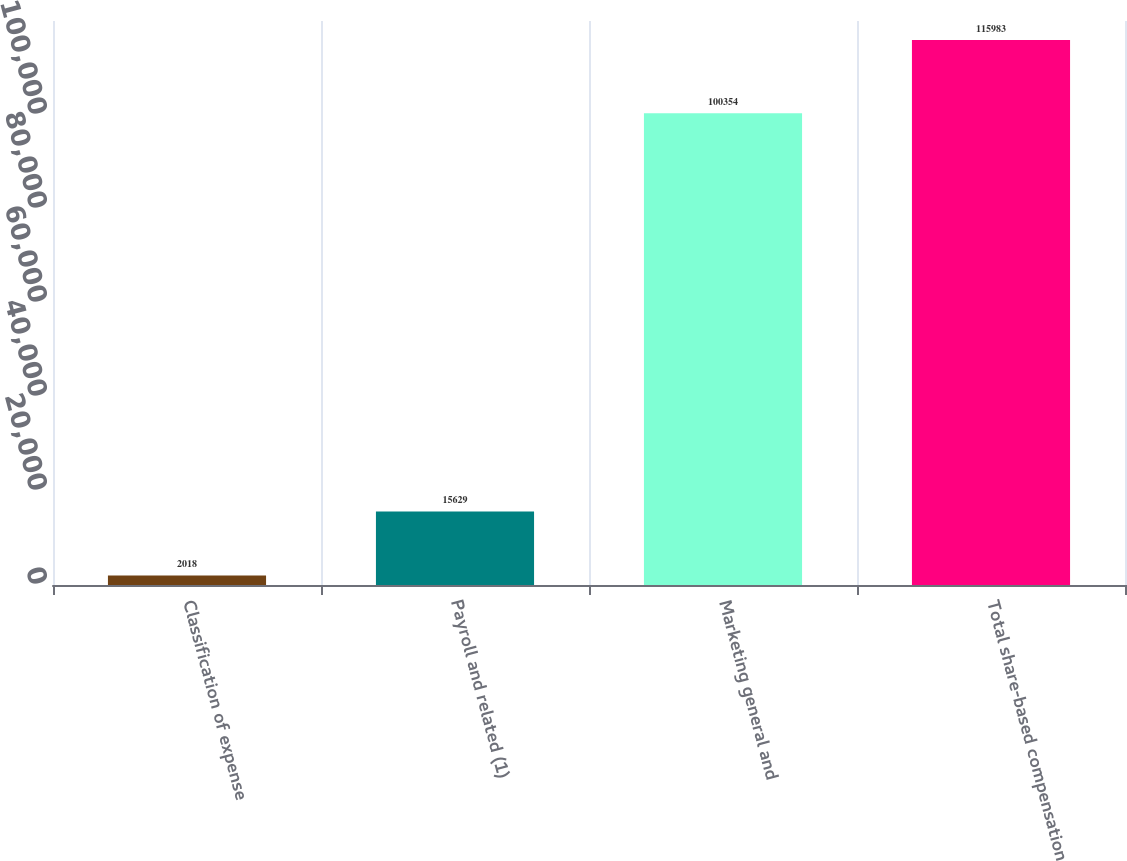Convert chart. <chart><loc_0><loc_0><loc_500><loc_500><bar_chart><fcel>Classification of expense<fcel>Payroll and related (1)<fcel>Marketing general and<fcel>Total share-based compensation<nl><fcel>2018<fcel>15629<fcel>100354<fcel>115983<nl></chart> 